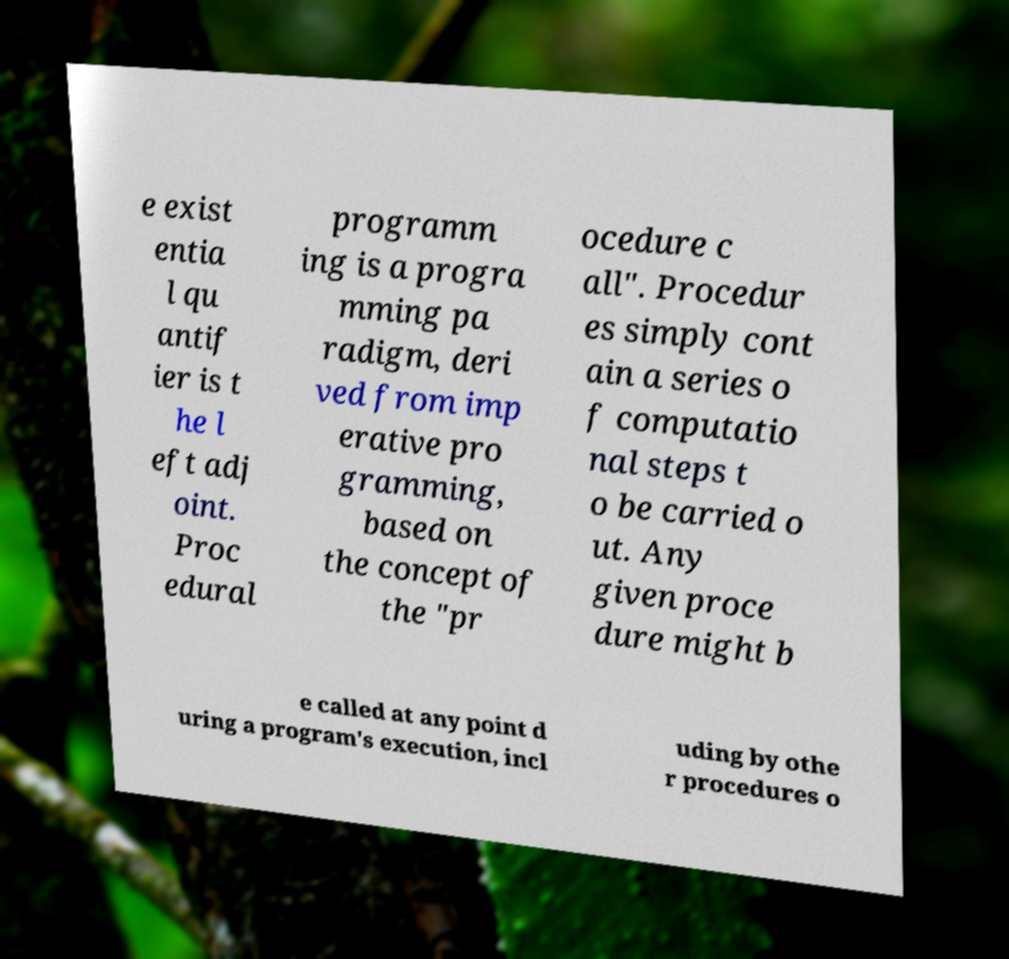Can you accurately transcribe the text from the provided image for me? e exist entia l qu antif ier is t he l eft adj oint. Proc edural programm ing is a progra mming pa radigm, deri ved from imp erative pro gramming, based on the concept of the "pr ocedure c all". Procedur es simply cont ain a series o f computatio nal steps t o be carried o ut. Any given proce dure might b e called at any point d uring a program's execution, incl uding by othe r procedures o 